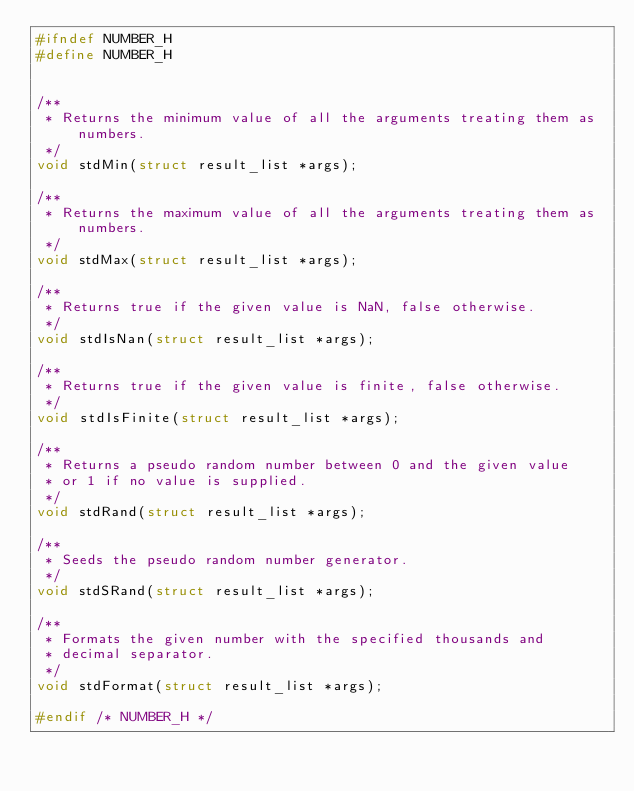Convert code to text. <code><loc_0><loc_0><loc_500><loc_500><_C_>#ifndef NUMBER_H
#define NUMBER_H


/**
 * Returns the minimum value of all the arguments treating them as numbers.
 */
void stdMin(struct result_list *args);

/**
 * Returns the maximum value of all the arguments treating them as numbers.
 */
void stdMax(struct result_list *args);

/**
 * Returns true if the given value is NaN, false otherwise.
 */
void stdIsNan(struct result_list *args);

/**
 * Returns true if the given value is finite, false otherwise.
 */
void stdIsFinite(struct result_list *args);

/**
 * Returns a pseudo random number between 0 and the given value
 * or 1 if no value is supplied.
 */
void stdRand(struct result_list *args);

/**
 * Seeds the pseudo random number generator.
 */
void stdSRand(struct result_list *args);

/**
 * Formats the given number with the specified thousands and
 * decimal separator.
 */
void stdFormat(struct result_list *args);

#endif /* NUMBER_H */
</code> 